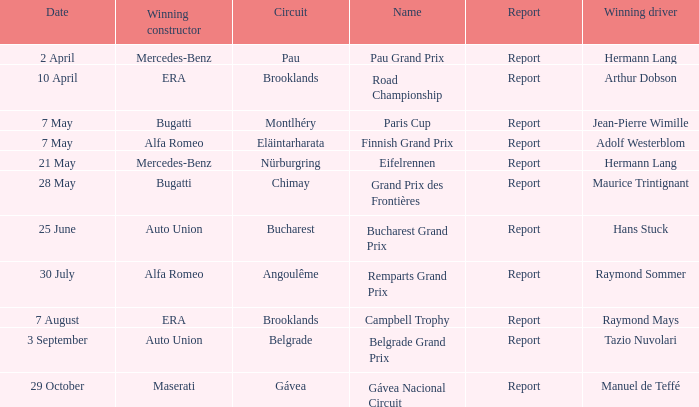Tell me the report for 30 july Report. 